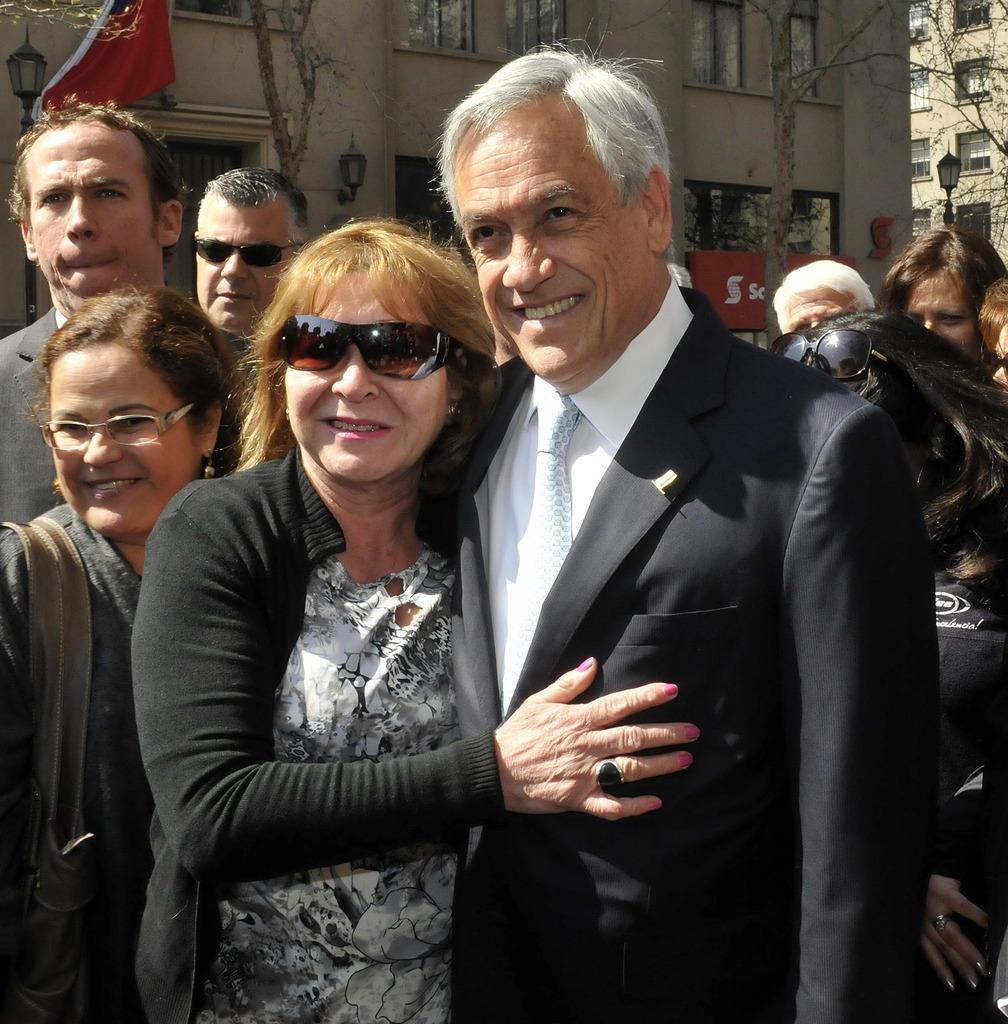Can you describe this image briefly? In this image there is a couple in the middle. In the background there are few people around the couple. In the background there is a building with the windows. On the left side top corner there is a flag beside the lamp. 